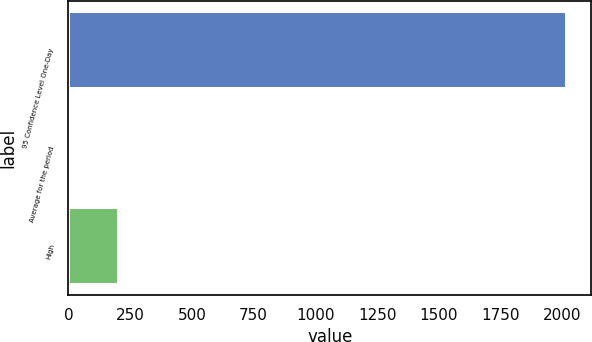Convert chart to OTSL. <chart><loc_0><loc_0><loc_500><loc_500><bar_chart><fcel>95 Confidence Level One-Day<fcel>Average for the period<fcel>High<nl><fcel>2016<fcel>2<fcel>203.4<nl></chart> 